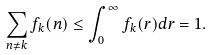Convert formula to latex. <formula><loc_0><loc_0><loc_500><loc_500>\sum _ { n \neq k } f _ { k } ( n ) \leq \int _ { 0 } ^ { \infty } f _ { k } ( r ) d r = 1 .</formula> 